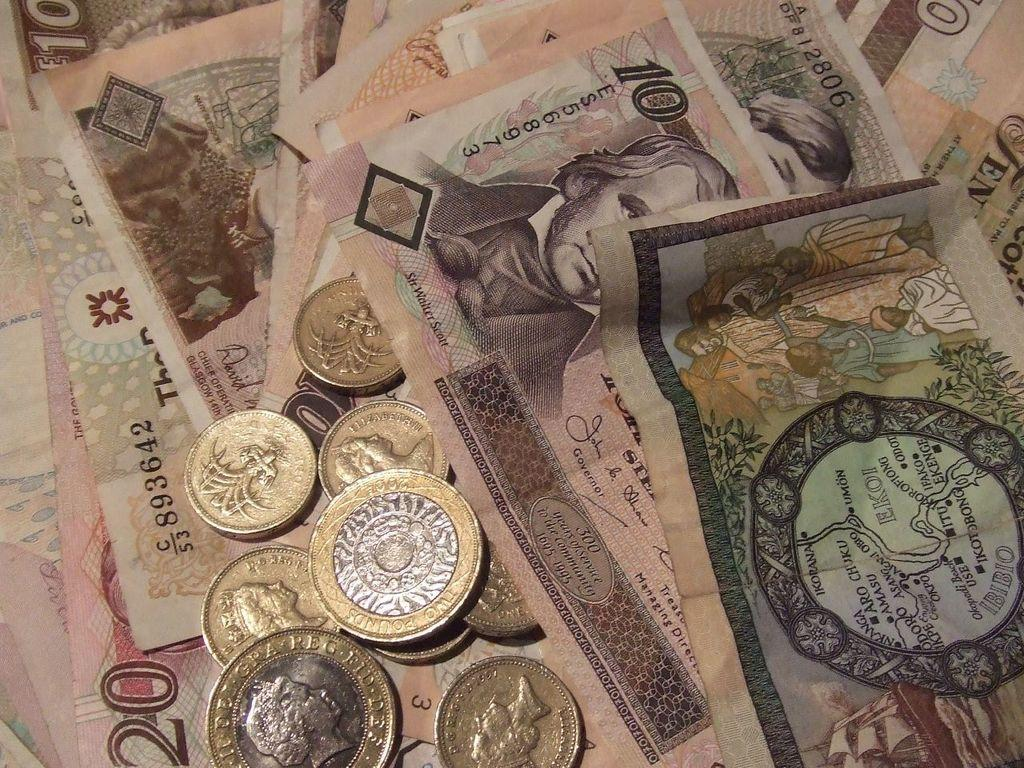Provide a one-sentence caption for the provided image. A bill has the word Governor below the signature. 